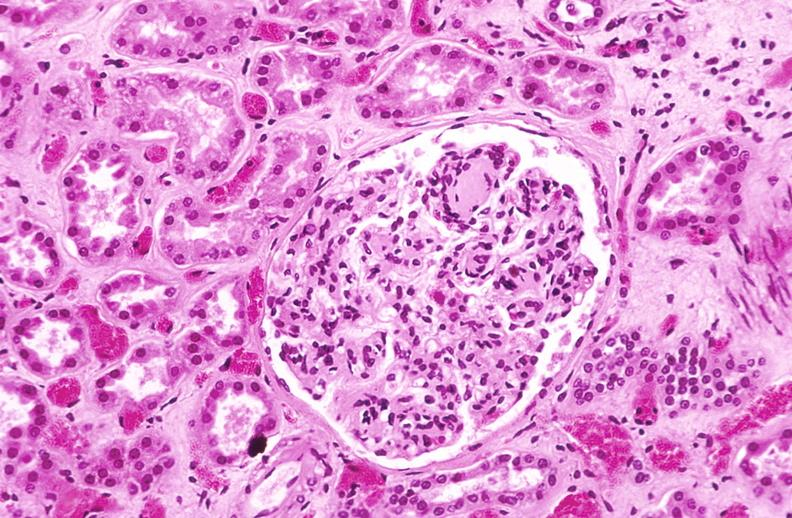does this image show kidney glomerulus, kimmelstiel-wilson nodules in a patient with diabetes mellitus?
Answer the question using a single word or phrase. Yes 